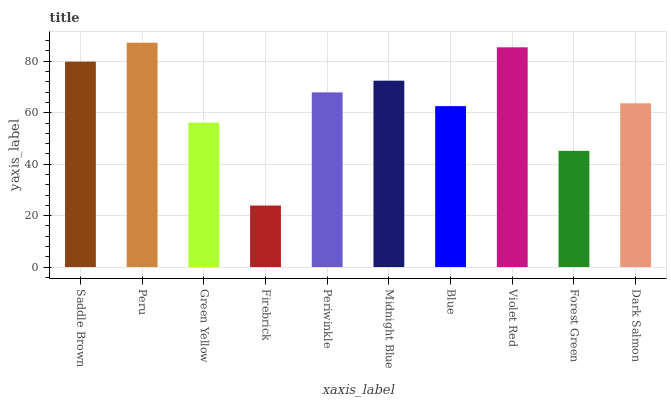Is Firebrick the minimum?
Answer yes or no. Yes. Is Peru the maximum?
Answer yes or no. Yes. Is Green Yellow the minimum?
Answer yes or no. No. Is Green Yellow the maximum?
Answer yes or no. No. Is Peru greater than Green Yellow?
Answer yes or no. Yes. Is Green Yellow less than Peru?
Answer yes or no. Yes. Is Green Yellow greater than Peru?
Answer yes or no. No. Is Peru less than Green Yellow?
Answer yes or no. No. Is Periwinkle the high median?
Answer yes or no. Yes. Is Dark Salmon the low median?
Answer yes or no. Yes. Is Midnight Blue the high median?
Answer yes or no. No. Is Periwinkle the low median?
Answer yes or no. No. 